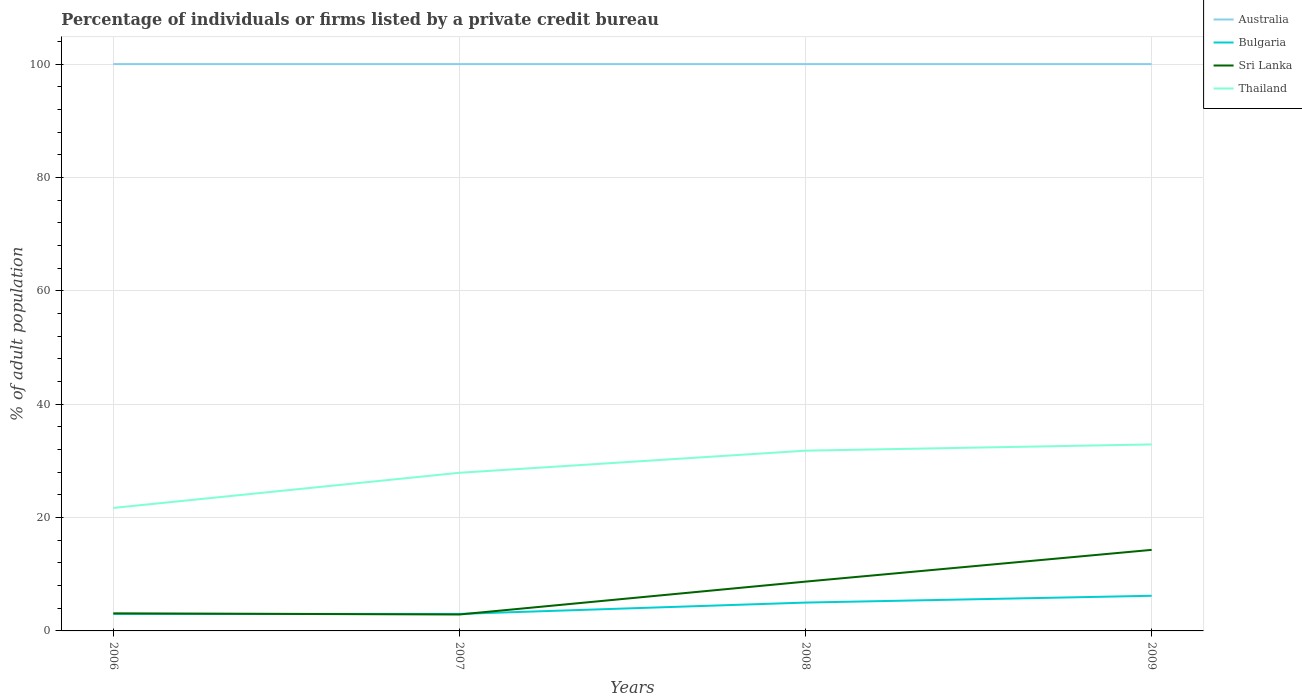How many different coloured lines are there?
Your answer should be compact. 4. Does the line corresponding to Australia intersect with the line corresponding to Thailand?
Your answer should be very brief. No. In which year was the percentage of population listed by a private credit bureau in Thailand maximum?
Make the answer very short. 2006. What is the total percentage of population listed by a private credit bureau in Australia in the graph?
Give a very brief answer. 0. Is the percentage of population listed by a private credit bureau in Australia strictly greater than the percentage of population listed by a private credit bureau in Sri Lanka over the years?
Offer a very short reply. No. How many lines are there?
Provide a short and direct response. 4. How many years are there in the graph?
Your response must be concise. 4. Does the graph contain any zero values?
Make the answer very short. No. Does the graph contain grids?
Give a very brief answer. Yes. What is the title of the graph?
Ensure brevity in your answer.  Percentage of individuals or firms listed by a private credit bureau. What is the label or title of the Y-axis?
Your response must be concise. % of adult population. What is the % of adult population of Thailand in 2006?
Ensure brevity in your answer.  21.7. What is the % of adult population in Australia in 2007?
Provide a succinct answer. 100. What is the % of adult population of Bulgaria in 2007?
Offer a terse response. 3. What is the % of adult population of Thailand in 2007?
Provide a succinct answer. 27.9. What is the % of adult population of Australia in 2008?
Keep it short and to the point. 100. What is the % of adult population in Sri Lanka in 2008?
Provide a short and direct response. 8.7. What is the % of adult population in Thailand in 2008?
Provide a short and direct response. 31.8. What is the % of adult population in Bulgaria in 2009?
Your response must be concise. 6.2. What is the % of adult population of Thailand in 2009?
Your answer should be very brief. 32.9. Across all years, what is the maximum % of adult population of Australia?
Offer a very short reply. 100. Across all years, what is the maximum % of adult population in Sri Lanka?
Give a very brief answer. 14.3. Across all years, what is the maximum % of adult population of Thailand?
Provide a short and direct response. 32.9. Across all years, what is the minimum % of adult population of Australia?
Ensure brevity in your answer.  100. Across all years, what is the minimum % of adult population in Thailand?
Your answer should be very brief. 21.7. What is the total % of adult population in Australia in the graph?
Your response must be concise. 400. What is the total % of adult population in Bulgaria in the graph?
Provide a succinct answer. 17.2. What is the total % of adult population of Sri Lanka in the graph?
Keep it short and to the point. 29. What is the total % of adult population in Thailand in the graph?
Provide a succinct answer. 114.3. What is the difference between the % of adult population in Australia in 2006 and that in 2007?
Offer a very short reply. 0. What is the difference between the % of adult population in Sri Lanka in 2006 and that in 2008?
Your answer should be very brief. -5.6. What is the difference between the % of adult population of Thailand in 2006 and that in 2009?
Your response must be concise. -11.2. What is the difference between the % of adult population of Thailand in 2007 and that in 2008?
Keep it short and to the point. -3.9. What is the difference between the % of adult population of Australia in 2007 and that in 2009?
Offer a terse response. 0. What is the difference between the % of adult population in Bulgaria in 2007 and that in 2009?
Your answer should be very brief. -3.2. What is the difference between the % of adult population of Sri Lanka in 2007 and that in 2009?
Offer a terse response. -11.4. What is the difference between the % of adult population in Thailand in 2007 and that in 2009?
Give a very brief answer. -5. What is the difference between the % of adult population of Australia in 2008 and that in 2009?
Ensure brevity in your answer.  0. What is the difference between the % of adult population of Bulgaria in 2008 and that in 2009?
Give a very brief answer. -1.2. What is the difference between the % of adult population in Sri Lanka in 2008 and that in 2009?
Give a very brief answer. -5.6. What is the difference between the % of adult population of Thailand in 2008 and that in 2009?
Keep it short and to the point. -1.1. What is the difference between the % of adult population of Australia in 2006 and the % of adult population of Bulgaria in 2007?
Provide a succinct answer. 97. What is the difference between the % of adult population of Australia in 2006 and the % of adult population of Sri Lanka in 2007?
Provide a succinct answer. 97.1. What is the difference between the % of adult population in Australia in 2006 and the % of adult population in Thailand in 2007?
Ensure brevity in your answer.  72.1. What is the difference between the % of adult population in Bulgaria in 2006 and the % of adult population in Sri Lanka in 2007?
Make the answer very short. 0.1. What is the difference between the % of adult population in Bulgaria in 2006 and the % of adult population in Thailand in 2007?
Ensure brevity in your answer.  -24.9. What is the difference between the % of adult population of Sri Lanka in 2006 and the % of adult population of Thailand in 2007?
Your answer should be very brief. -24.8. What is the difference between the % of adult population of Australia in 2006 and the % of adult population of Bulgaria in 2008?
Offer a very short reply. 95. What is the difference between the % of adult population of Australia in 2006 and the % of adult population of Sri Lanka in 2008?
Give a very brief answer. 91.3. What is the difference between the % of adult population in Australia in 2006 and the % of adult population in Thailand in 2008?
Your response must be concise. 68.2. What is the difference between the % of adult population of Bulgaria in 2006 and the % of adult population of Sri Lanka in 2008?
Provide a succinct answer. -5.7. What is the difference between the % of adult population in Bulgaria in 2006 and the % of adult population in Thailand in 2008?
Make the answer very short. -28.8. What is the difference between the % of adult population in Sri Lanka in 2006 and the % of adult population in Thailand in 2008?
Give a very brief answer. -28.7. What is the difference between the % of adult population in Australia in 2006 and the % of adult population in Bulgaria in 2009?
Ensure brevity in your answer.  93.8. What is the difference between the % of adult population of Australia in 2006 and the % of adult population of Sri Lanka in 2009?
Provide a short and direct response. 85.7. What is the difference between the % of adult population of Australia in 2006 and the % of adult population of Thailand in 2009?
Your response must be concise. 67.1. What is the difference between the % of adult population of Bulgaria in 2006 and the % of adult population of Sri Lanka in 2009?
Offer a very short reply. -11.3. What is the difference between the % of adult population of Bulgaria in 2006 and the % of adult population of Thailand in 2009?
Keep it short and to the point. -29.9. What is the difference between the % of adult population in Sri Lanka in 2006 and the % of adult population in Thailand in 2009?
Provide a succinct answer. -29.8. What is the difference between the % of adult population in Australia in 2007 and the % of adult population in Sri Lanka in 2008?
Ensure brevity in your answer.  91.3. What is the difference between the % of adult population in Australia in 2007 and the % of adult population in Thailand in 2008?
Your response must be concise. 68.2. What is the difference between the % of adult population of Bulgaria in 2007 and the % of adult population of Sri Lanka in 2008?
Ensure brevity in your answer.  -5.7. What is the difference between the % of adult population of Bulgaria in 2007 and the % of adult population of Thailand in 2008?
Your answer should be compact. -28.8. What is the difference between the % of adult population of Sri Lanka in 2007 and the % of adult population of Thailand in 2008?
Your answer should be compact. -28.9. What is the difference between the % of adult population in Australia in 2007 and the % of adult population in Bulgaria in 2009?
Give a very brief answer. 93.8. What is the difference between the % of adult population of Australia in 2007 and the % of adult population of Sri Lanka in 2009?
Give a very brief answer. 85.7. What is the difference between the % of adult population in Australia in 2007 and the % of adult population in Thailand in 2009?
Your answer should be very brief. 67.1. What is the difference between the % of adult population in Bulgaria in 2007 and the % of adult population in Thailand in 2009?
Keep it short and to the point. -29.9. What is the difference between the % of adult population in Sri Lanka in 2007 and the % of adult population in Thailand in 2009?
Offer a terse response. -30. What is the difference between the % of adult population in Australia in 2008 and the % of adult population in Bulgaria in 2009?
Offer a very short reply. 93.8. What is the difference between the % of adult population in Australia in 2008 and the % of adult population in Sri Lanka in 2009?
Provide a short and direct response. 85.7. What is the difference between the % of adult population of Australia in 2008 and the % of adult population of Thailand in 2009?
Make the answer very short. 67.1. What is the difference between the % of adult population of Bulgaria in 2008 and the % of adult population of Thailand in 2009?
Your answer should be compact. -27.9. What is the difference between the % of adult population of Sri Lanka in 2008 and the % of adult population of Thailand in 2009?
Make the answer very short. -24.2. What is the average % of adult population of Sri Lanka per year?
Offer a terse response. 7.25. What is the average % of adult population of Thailand per year?
Make the answer very short. 28.57. In the year 2006, what is the difference between the % of adult population of Australia and % of adult population of Bulgaria?
Provide a short and direct response. 97. In the year 2006, what is the difference between the % of adult population of Australia and % of adult population of Sri Lanka?
Ensure brevity in your answer.  96.9. In the year 2006, what is the difference between the % of adult population of Australia and % of adult population of Thailand?
Offer a terse response. 78.3. In the year 2006, what is the difference between the % of adult population in Bulgaria and % of adult population in Sri Lanka?
Offer a very short reply. -0.1. In the year 2006, what is the difference between the % of adult population in Bulgaria and % of adult population in Thailand?
Your answer should be very brief. -18.7. In the year 2006, what is the difference between the % of adult population in Sri Lanka and % of adult population in Thailand?
Provide a succinct answer. -18.6. In the year 2007, what is the difference between the % of adult population in Australia and % of adult population in Bulgaria?
Your response must be concise. 97. In the year 2007, what is the difference between the % of adult population of Australia and % of adult population of Sri Lanka?
Your answer should be compact. 97.1. In the year 2007, what is the difference between the % of adult population of Australia and % of adult population of Thailand?
Provide a short and direct response. 72.1. In the year 2007, what is the difference between the % of adult population in Bulgaria and % of adult population in Sri Lanka?
Offer a terse response. 0.1. In the year 2007, what is the difference between the % of adult population in Bulgaria and % of adult population in Thailand?
Offer a very short reply. -24.9. In the year 2007, what is the difference between the % of adult population in Sri Lanka and % of adult population in Thailand?
Provide a short and direct response. -25. In the year 2008, what is the difference between the % of adult population in Australia and % of adult population in Sri Lanka?
Offer a terse response. 91.3. In the year 2008, what is the difference between the % of adult population in Australia and % of adult population in Thailand?
Offer a very short reply. 68.2. In the year 2008, what is the difference between the % of adult population of Bulgaria and % of adult population of Thailand?
Provide a succinct answer. -26.8. In the year 2008, what is the difference between the % of adult population in Sri Lanka and % of adult population in Thailand?
Your answer should be very brief. -23.1. In the year 2009, what is the difference between the % of adult population in Australia and % of adult population in Bulgaria?
Your answer should be compact. 93.8. In the year 2009, what is the difference between the % of adult population of Australia and % of adult population of Sri Lanka?
Make the answer very short. 85.7. In the year 2009, what is the difference between the % of adult population in Australia and % of adult population in Thailand?
Your answer should be compact. 67.1. In the year 2009, what is the difference between the % of adult population of Bulgaria and % of adult population of Thailand?
Offer a terse response. -26.7. In the year 2009, what is the difference between the % of adult population of Sri Lanka and % of adult population of Thailand?
Your response must be concise. -18.6. What is the ratio of the % of adult population in Australia in 2006 to that in 2007?
Your response must be concise. 1. What is the ratio of the % of adult population in Sri Lanka in 2006 to that in 2007?
Your answer should be compact. 1.07. What is the ratio of the % of adult population of Thailand in 2006 to that in 2007?
Your answer should be compact. 0.78. What is the ratio of the % of adult population in Australia in 2006 to that in 2008?
Give a very brief answer. 1. What is the ratio of the % of adult population in Bulgaria in 2006 to that in 2008?
Provide a succinct answer. 0.6. What is the ratio of the % of adult population in Sri Lanka in 2006 to that in 2008?
Your answer should be very brief. 0.36. What is the ratio of the % of adult population in Thailand in 2006 to that in 2008?
Make the answer very short. 0.68. What is the ratio of the % of adult population of Australia in 2006 to that in 2009?
Keep it short and to the point. 1. What is the ratio of the % of adult population in Bulgaria in 2006 to that in 2009?
Give a very brief answer. 0.48. What is the ratio of the % of adult population in Sri Lanka in 2006 to that in 2009?
Make the answer very short. 0.22. What is the ratio of the % of adult population of Thailand in 2006 to that in 2009?
Your answer should be very brief. 0.66. What is the ratio of the % of adult population in Australia in 2007 to that in 2008?
Your answer should be very brief. 1. What is the ratio of the % of adult population in Bulgaria in 2007 to that in 2008?
Your response must be concise. 0.6. What is the ratio of the % of adult population in Thailand in 2007 to that in 2008?
Offer a very short reply. 0.88. What is the ratio of the % of adult population in Australia in 2007 to that in 2009?
Provide a succinct answer. 1. What is the ratio of the % of adult population in Bulgaria in 2007 to that in 2009?
Ensure brevity in your answer.  0.48. What is the ratio of the % of adult population in Sri Lanka in 2007 to that in 2009?
Provide a succinct answer. 0.2. What is the ratio of the % of adult population of Thailand in 2007 to that in 2009?
Your answer should be compact. 0.85. What is the ratio of the % of adult population of Australia in 2008 to that in 2009?
Your answer should be compact. 1. What is the ratio of the % of adult population in Bulgaria in 2008 to that in 2009?
Offer a terse response. 0.81. What is the ratio of the % of adult population in Sri Lanka in 2008 to that in 2009?
Keep it short and to the point. 0.61. What is the ratio of the % of adult population of Thailand in 2008 to that in 2009?
Your answer should be compact. 0.97. What is the difference between the highest and the second highest % of adult population of Australia?
Your response must be concise. 0. What is the difference between the highest and the second highest % of adult population in Sri Lanka?
Offer a terse response. 5.6. What is the difference between the highest and the lowest % of adult population in Australia?
Keep it short and to the point. 0. What is the difference between the highest and the lowest % of adult population in Bulgaria?
Make the answer very short. 3.2. What is the difference between the highest and the lowest % of adult population in Sri Lanka?
Keep it short and to the point. 11.4. 